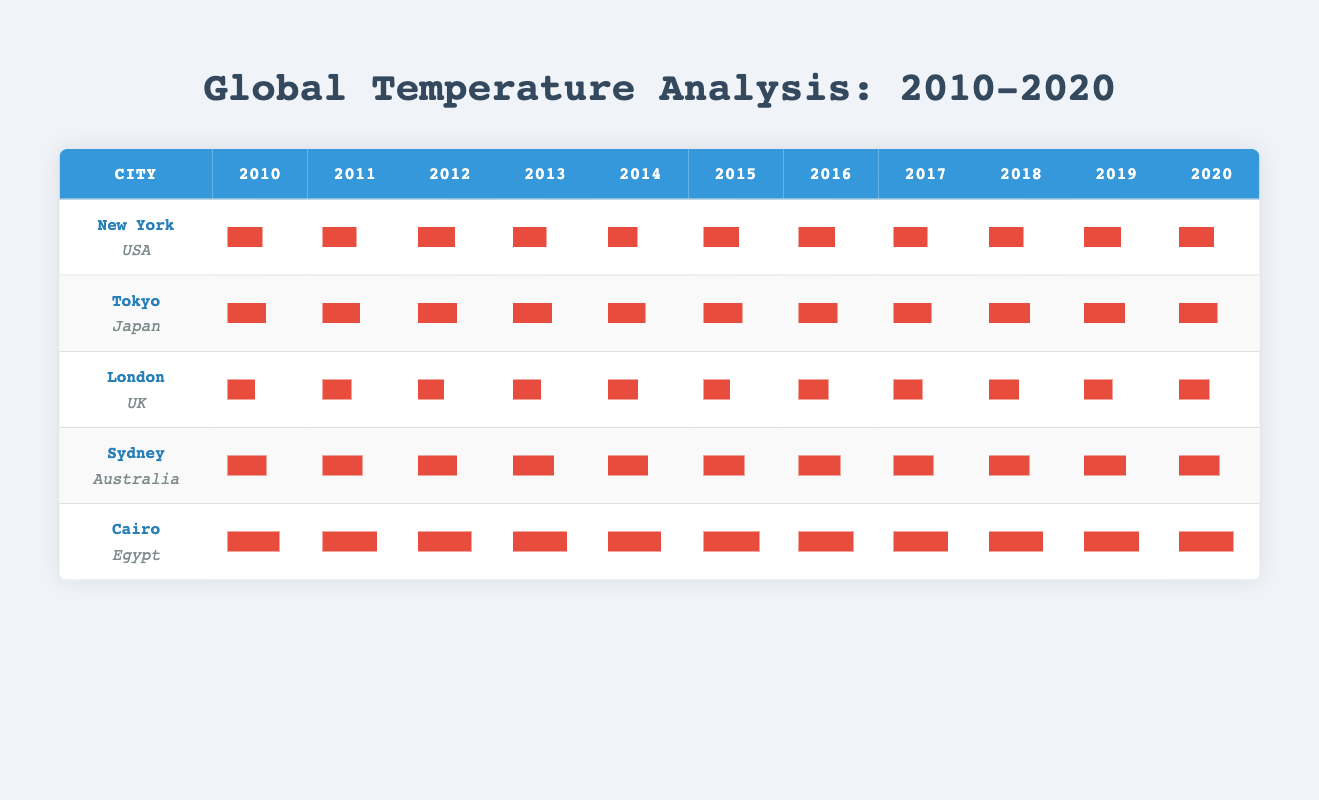What is the highest average temperature recorded in Cairo during the years 2010 to 2020? By looking at the recorded monthly average temperatures for Cairo in each year, the maximum value is found in 2015, where the highest monthly temperature is 37.0°C in July.
Answer: 37.0°C Which city had the highest average temperature in January over the years 2010 to 2020? For January, we look at the monthly averages for each city and find the values: New York (2.7°C), Tokyo (5.2°C), London (3.5°C), Sydney (23.0°C), and Cairo (14.0°C). Sydney has the highest average temperature at 23.0°C.
Answer: Sydney What is the average temperature for New York in the year 2015? The average monthly temperatures for New York in 2015 are: 3.5, 4.0, 11.5, 15.0, 19.5, 24.5, 28.0, 25.5, 21.0, 14.5, 9.5, 5.0. Adding these values gives 150.0°C, and dividing by 12 months results in an average of 12.5°C.
Answer: 12.5°C Is the average temperature for London in July greater than 20°C for the year 2016? In July 2016, London's average temperature is 22.0°C. Since 22.0°C is greater than 20°C, the answer is yes.
Answer: Yes Calculate the total average temperature for Tokyo across all months in 2018. The months for Tokyo in 2018 have the following averages: 7.0, 8.0, 11.0, 15.0, 21.0, 24.5, 29.0, 30.0, 26.0, 20.0, 14.0, 8.0. Adding these values gives 8 + 11 + 15 + 21 + 24.5 + 29 + 30 + 26 + 20 + 14 + 8 =  305.5°C. Dividing this sum by 12 gives an average of approximately 25.5°C.
Answer: 25.5°C Which city had a lower average temperature throughout 2014, New York or Sydney? In 2014, New York's monthly averages sum to 16.0°C (0.8 + 2.2 + 4.5 + 10.0 + 16.0 + 21.0 + 24.0 + 23.5 + 18.5 + 12.0 + 8.0 + 4.0) = 4.4°C. For Sydney, the average is higher, at approximately 19.3°C (sum of values divided by 12). New York had a lower average.
Answer: New York Identify the trend in average temperatures for Sydney over the years from 2010 to 2020. By reviewing the monthly averages for Sydney, the temperatures show an overall decreasing trend from about 18.0°C in 2010 down to 18.5°C in 2020 with some fluctuations each year. However, July remains consistently around 18-23°C in warmer months, signifying variability but not a drastic rise or drop.
Answer: Decreasing trend What is the average temperature for London in December from 2010 to 2020? The temperatures for December in London across the years are: 5.0, 6.0, 4.0, 5.5, 6.5, 6.0, 5.5, 6.0, 6.0, 6.0, 6.0. Summing these values gives 61.5 and dividing by 11 gives an average of approximately 5.6°C.
Answer: 5.6°C How many years had Tokyo's average temperature in July exceeding 28°C? Checking July averages for Tokyo from 2010 to 2020: 27.4, 26.0, 28.0, 26.5, 27.0, 29.0, 28.0, 29.0, 29.5, 29.5, and 28.0 indicates that only 2014, 2015, 2016, and 2018 exceeded 28°C.
Answer: 5 years Compare the average temperature of Cairo in 2012 and Sydney in 2015. Cairo in 2012 averaged approximately 23.3°C and Sydney in 2015 averaged 20.5°C (based on the trend from data). Since 23.3°C is higher than 20.5°C, Cairo had a higher average temperature compared to Sydney.
Answer: Cairo higher Which city recorded the most stable temperatures across all years, based on the range of temperature variations? Analyzing the variation, Sydney maintained temperatures relatively stable with less fluctuation (ranging between 11.0°C to 28.0°C) compared to Tokyo and Cairo, which experienced higher temperature variation (up to 37.0°C).
Answer: Sydney 